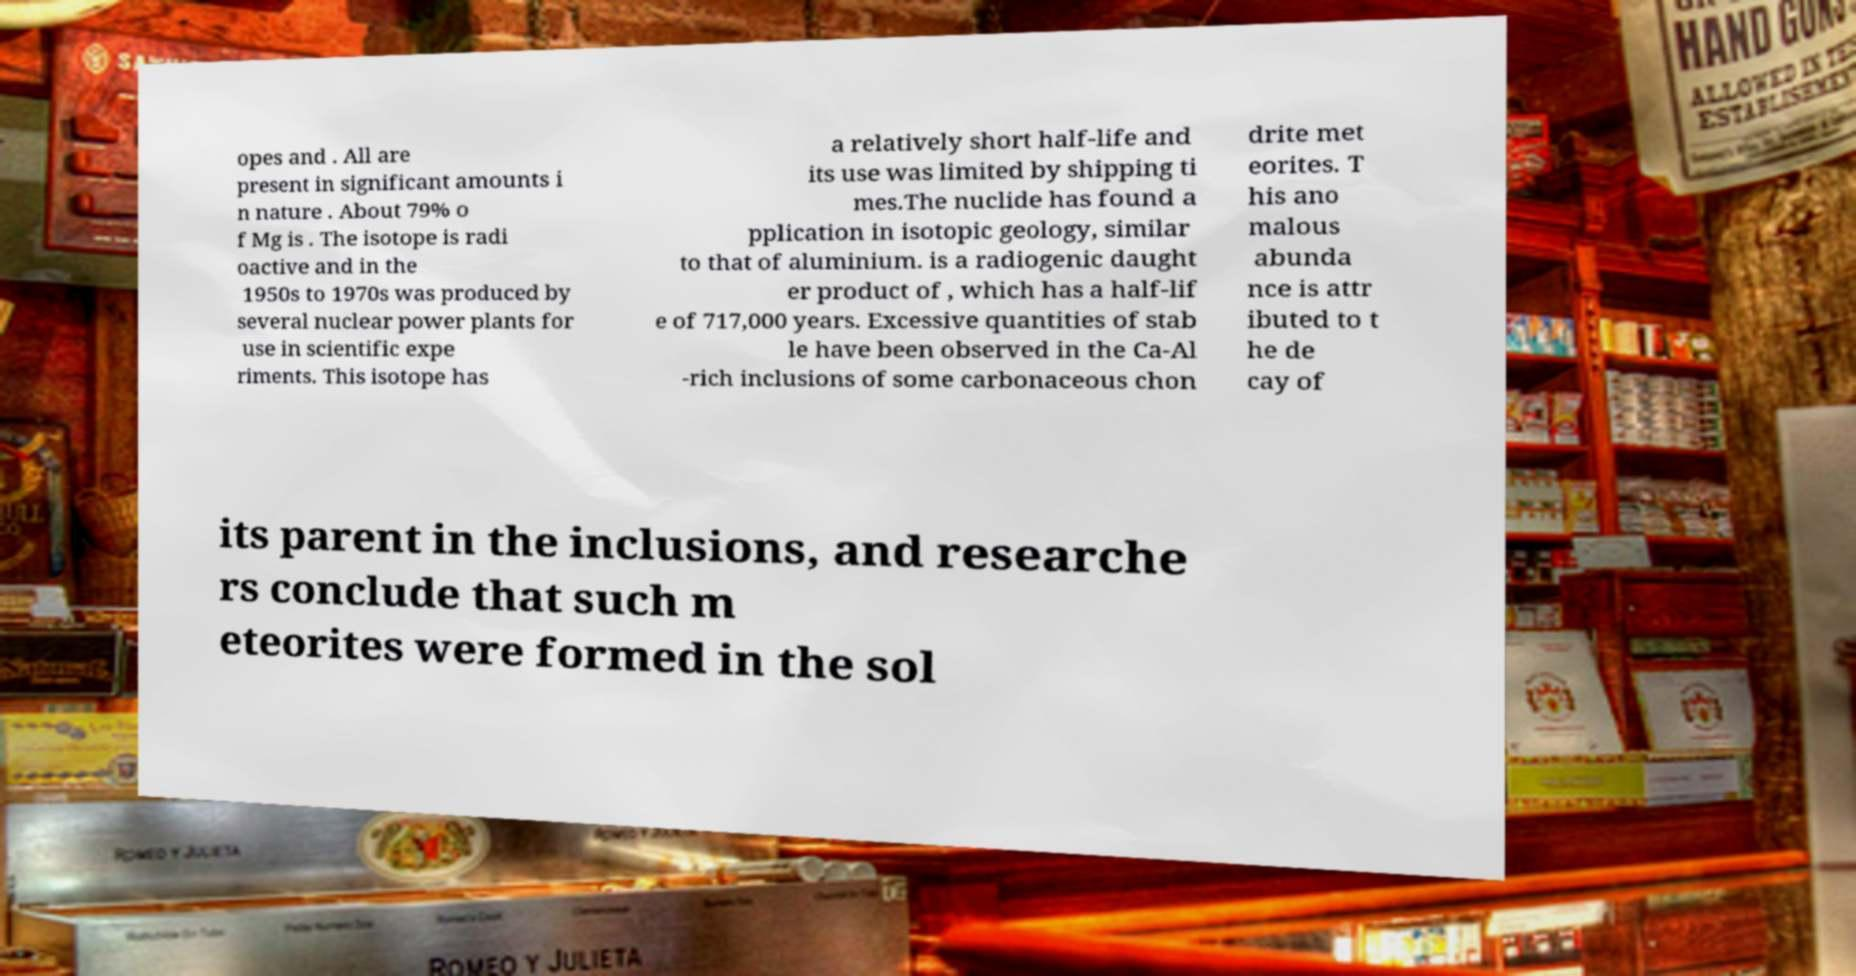There's text embedded in this image that I need extracted. Can you transcribe it verbatim? opes and . All are present in significant amounts i n nature . About 79% o f Mg is . The isotope is radi oactive and in the 1950s to 1970s was produced by several nuclear power plants for use in scientific expe riments. This isotope has a relatively short half-life and its use was limited by shipping ti mes.The nuclide has found a pplication in isotopic geology, similar to that of aluminium. is a radiogenic daught er product of , which has a half-lif e of 717,000 years. Excessive quantities of stab le have been observed in the Ca-Al -rich inclusions of some carbonaceous chon drite met eorites. T his ano malous abunda nce is attr ibuted to t he de cay of its parent in the inclusions, and researche rs conclude that such m eteorites were formed in the sol 